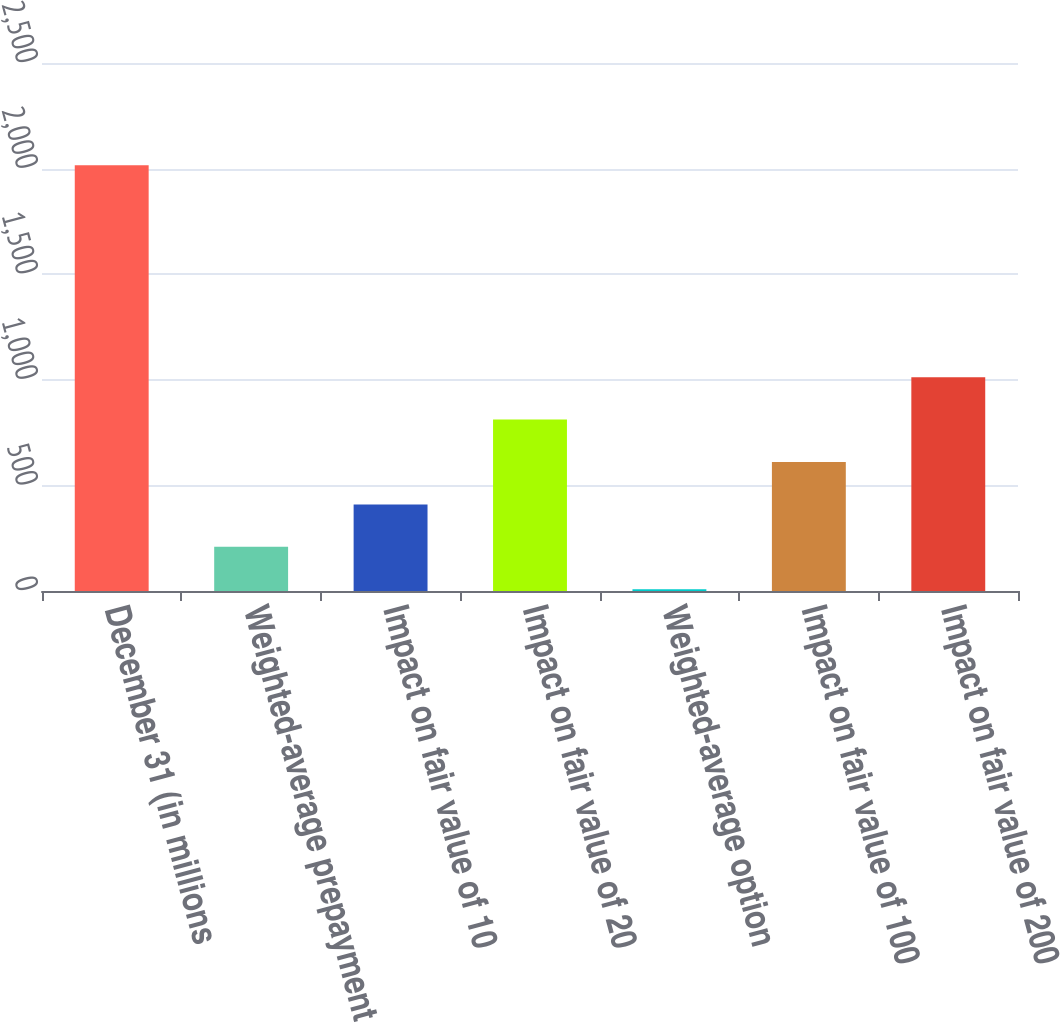Convert chart to OTSL. <chart><loc_0><loc_0><loc_500><loc_500><bar_chart><fcel>December 31 (in millions<fcel>Weighted-average prepayment<fcel>Impact on fair value of 10<fcel>Impact on fair value of 20<fcel>Weighted-average option<fcel>Impact on fair value of 100<fcel>Impact on fair value of 200<nl><fcel>2016<fcel>209.3<fcel>410.05<fcel>811.54<fcel>8.55<fcel>610.8<fcel>1012.28<nl></chart> 